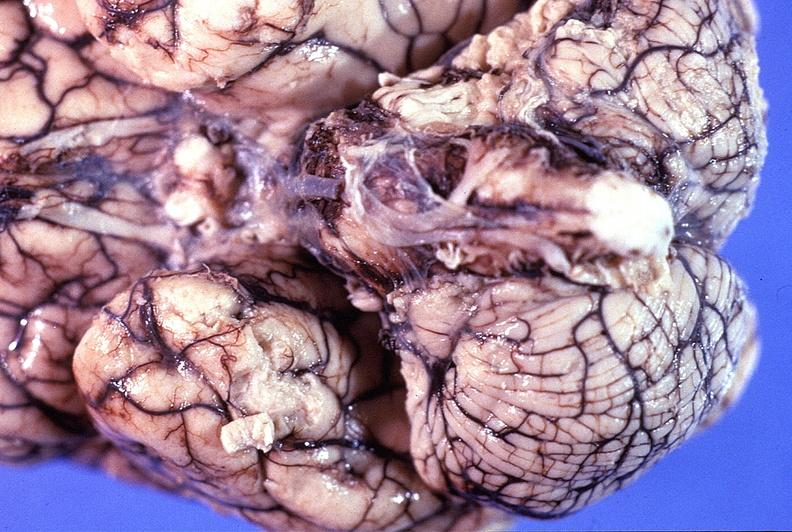what is present?
Answer the question using a single word or phrase. Nervous 